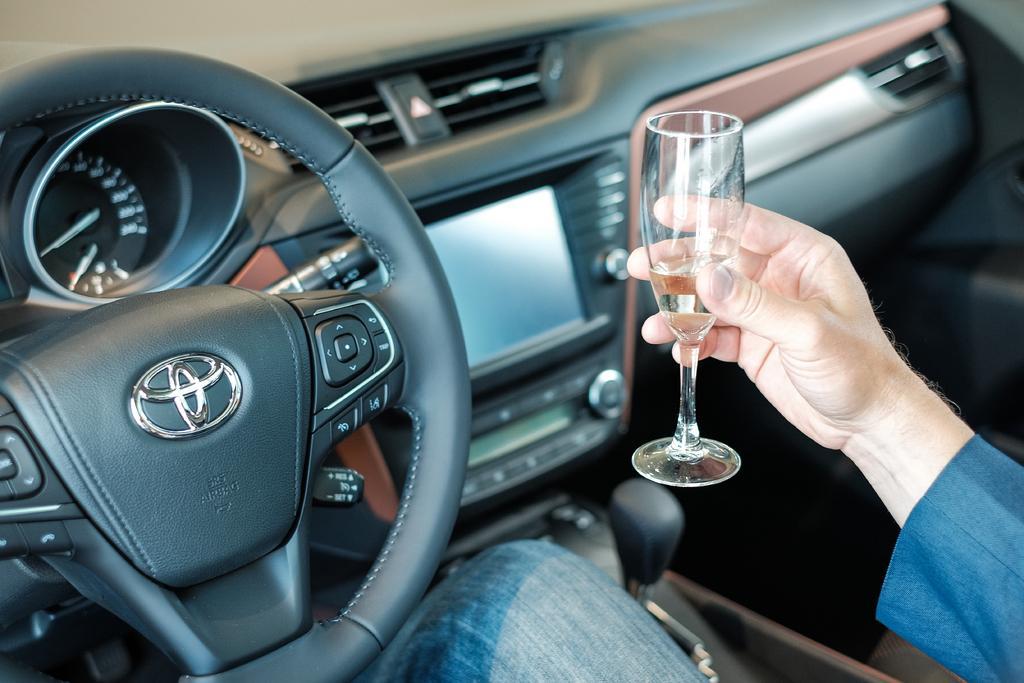Please provide a concise description of this image. In this picture we can see the inside view of the car, a man is sitting and holding the wine glass. Behind we can see the car steering and center console with lcd screen and buttons. 